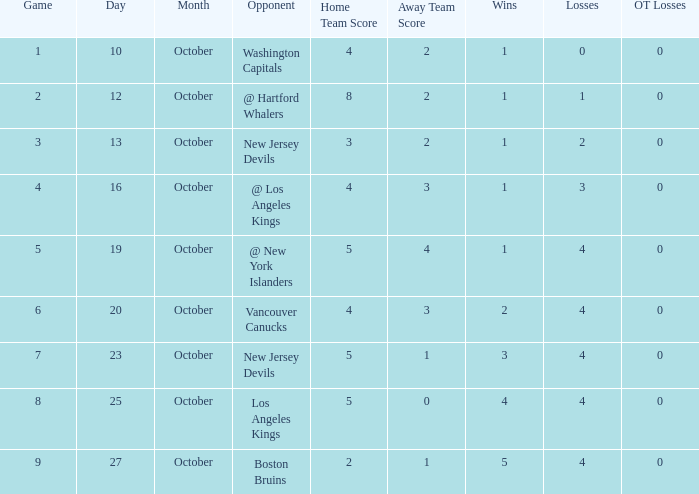Which game has the highest score in October with 9? 27.0. 